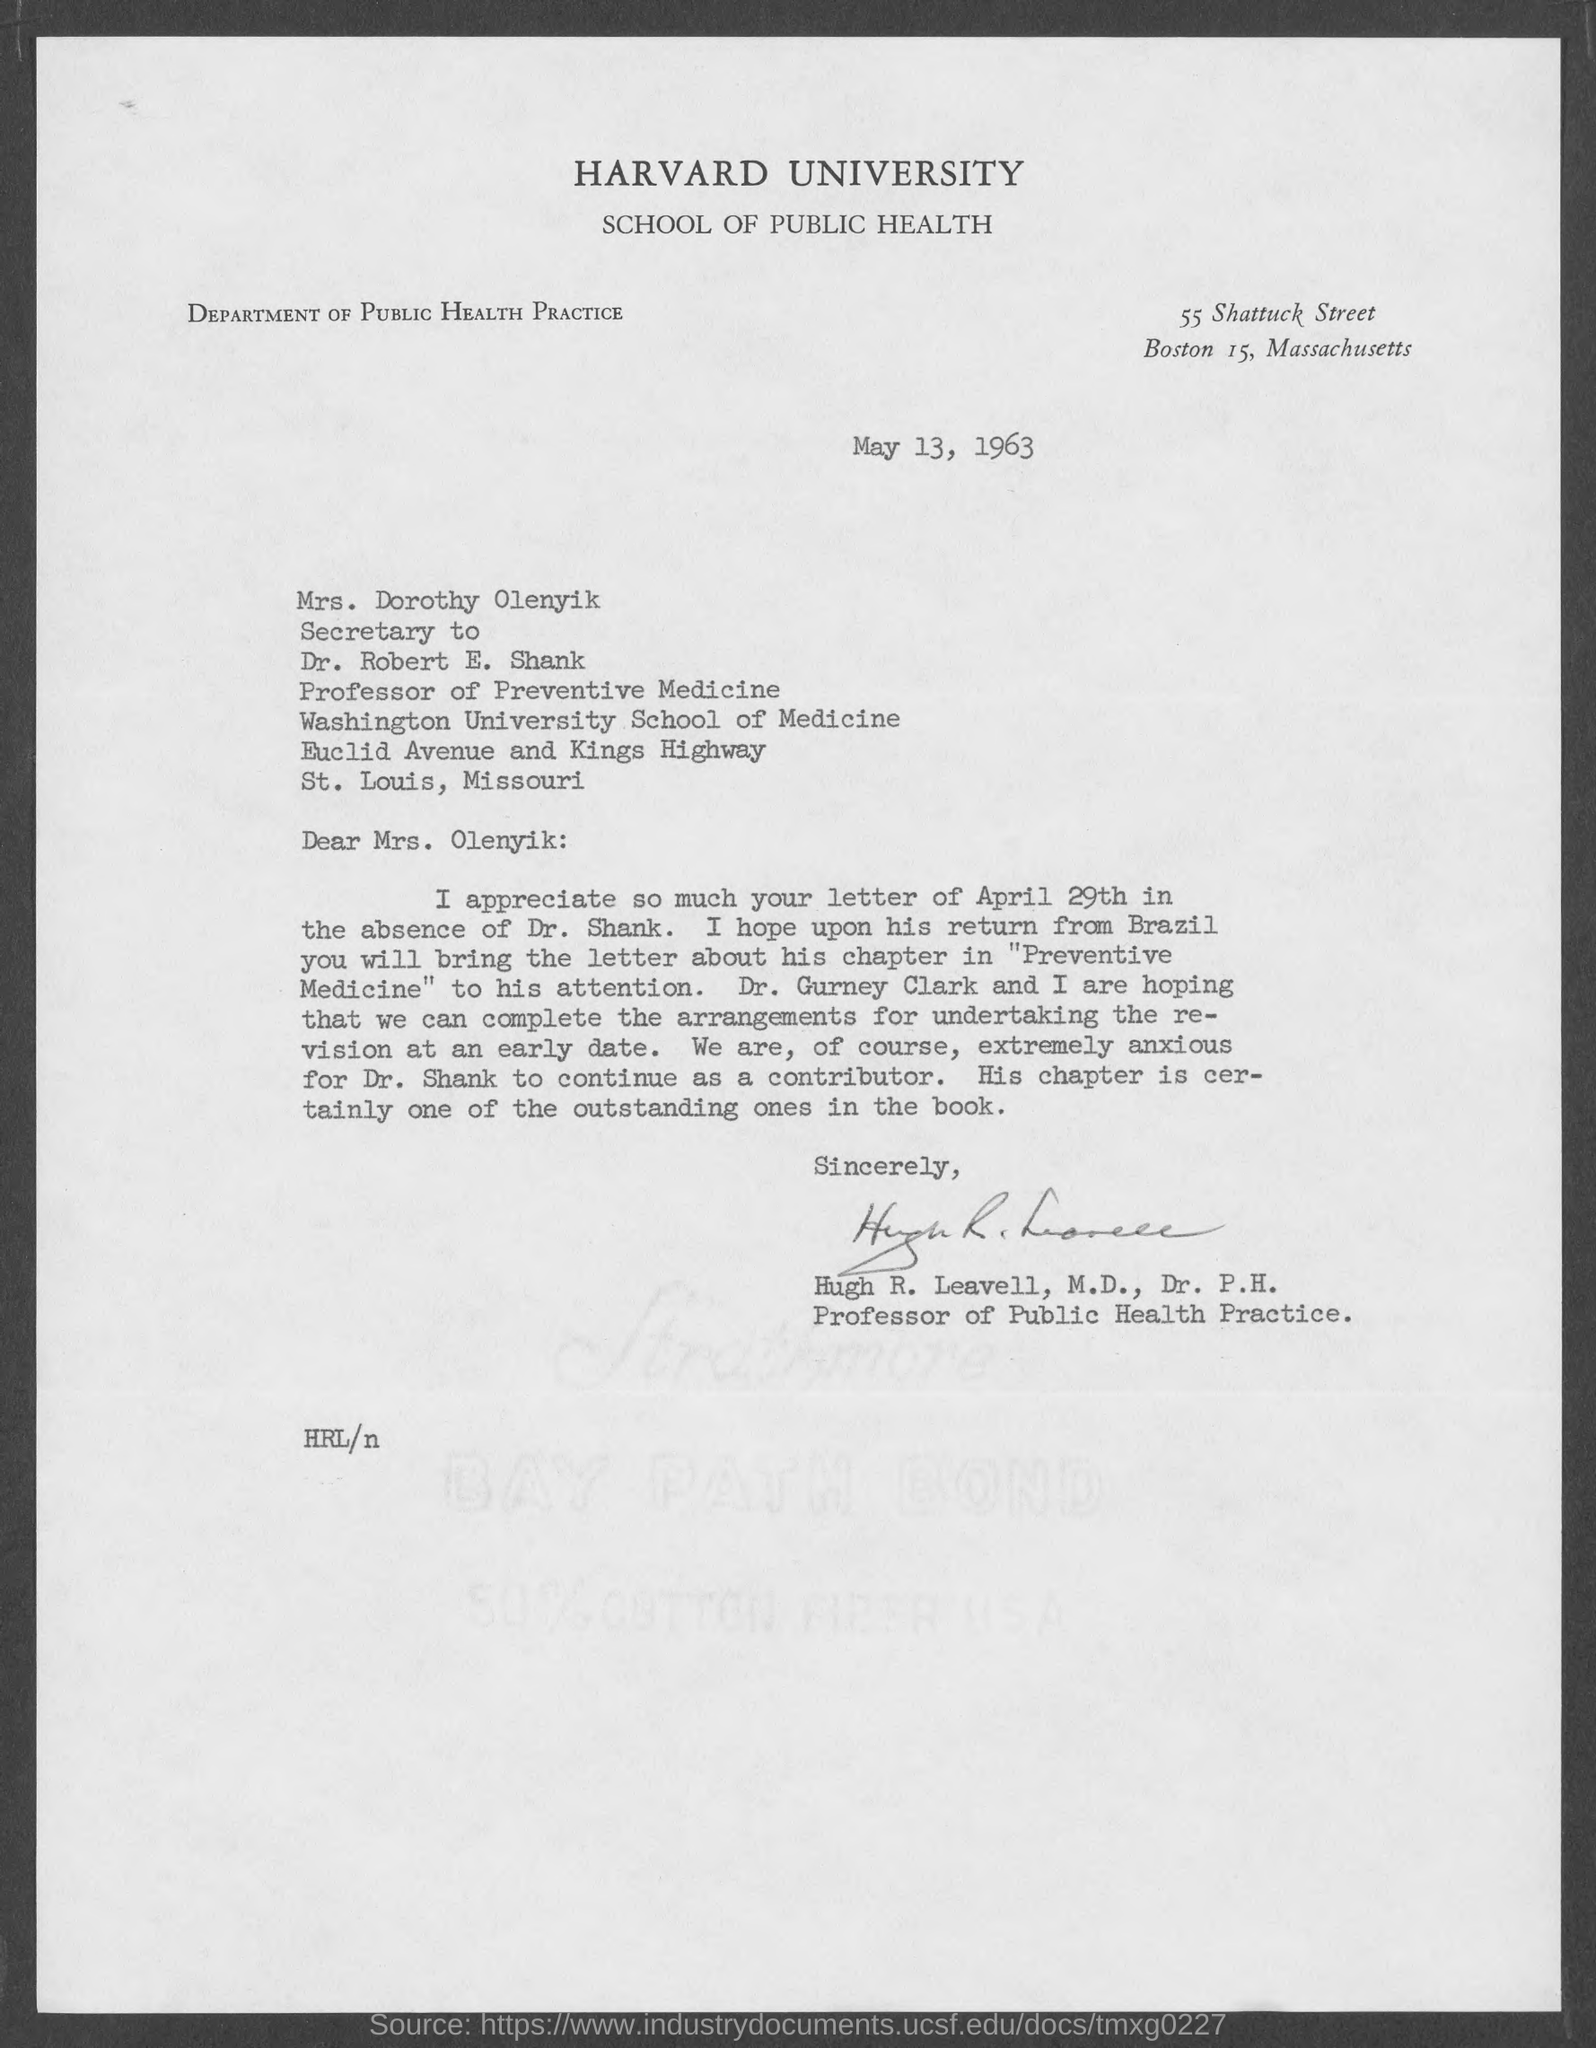Who wrote this letter?
Make the answer very short. Hugh R. Leavell. Who is the secretary to dr. robert e. shank?
Keep it short and to the point. Mrs. Dorothy Olenyik. 